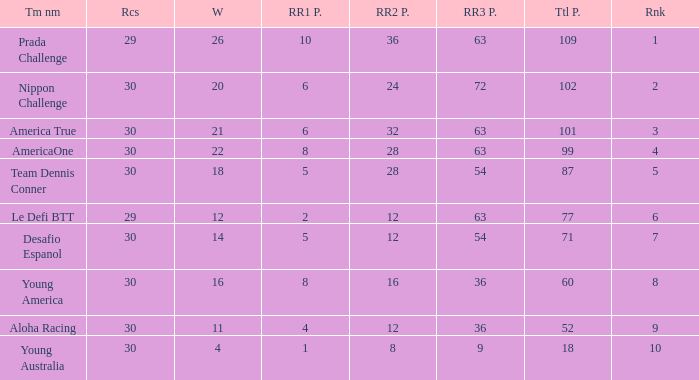Name the most rr1 pts for 7 ranking 5.0. 